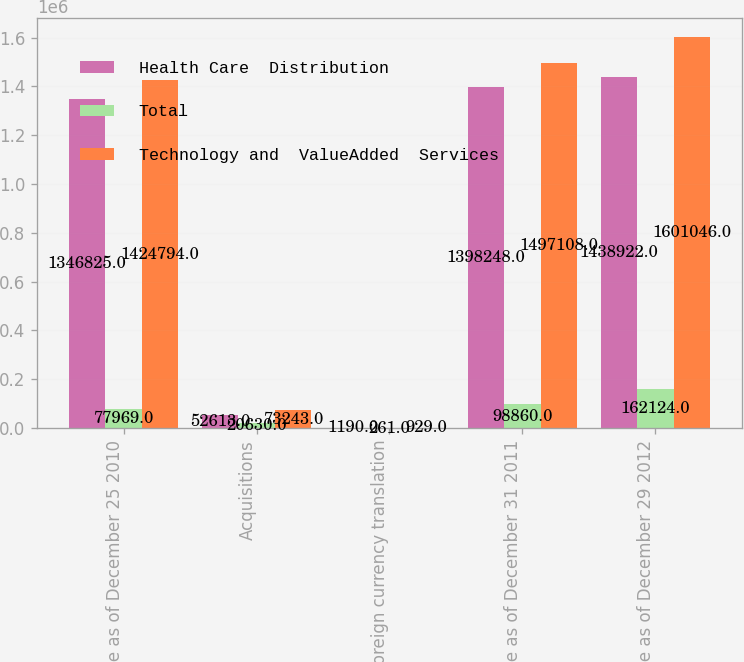Convert chart. <chart><loc_0><loc_0><loc_500><loc_500><stacked_bar_chart><ecel><fcel>Balance as of December 25 2010<fcel>Acquisitions<fcel>Foreign currency translation<fcel>Balance as of December 31 2011<fcel>Balance as of December 29 2012<nl><fcel>Health Care  Distribution<fcel>1.34682e+06<fcel>52613<fcel>1190<fcel>1.39825e+06<fcel>1.43892e+06<nl><fcel>Total<fcel>77969<fcel>20630<fcel>261<fcel>98860<fcel>162124<nl><fcel>Technology and  ValueAdded  Services<fcel>1.42479e+06<fcel>73243<fcel>929<fcel>1.49711e+06<fcel>1.60105e+06<nl></chart> 